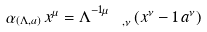<formula> <loc_0><loc_0><loc_500><loc_500>\alpha _ { ( \Lambda , a ) } \, x ^ { \mu } = { \Lambda } ^ { - 1 \mu } _ { \, \quad , \nu } \, ( x ^ { \nu } - { 1 } \, a ^ { \nu } )</formula> 